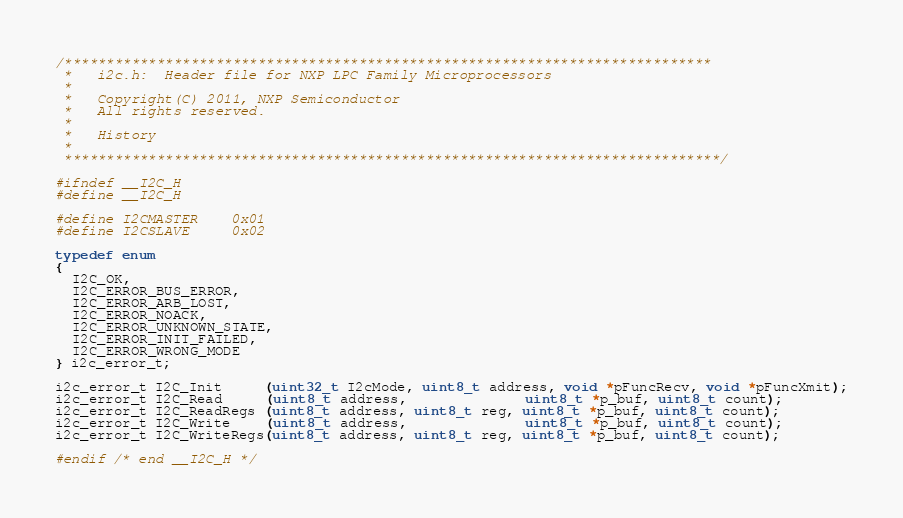Convert code to text. <code><loc_0><loc_0><loc_500><loc_500><_C_>/*****************************************************************************
 *   i2c.h:  Header file for NXP LPC Family Microprocessors
 *
 *   Copyright(C) 2011, NXP Semiconductor
 *   All rights reserved.
 *
 *   History
 *
 ******************************************************************************/

#ifndef __I2C_H
#define __I2C_H

#define I2CMASTER    0x01
#define I2CSLAVE     0x02

typedef enum
{
  I2C_OK,
  I2C_ERROR_BUS_ERROR,
  I2C_ERROR_ARB_LOST,
  I2C_ERROR_NOACK,
  I2C_ERROR_UNKNOWN_STATE,
  I2C_ERROR_INIT_FAILED,
  I2C_ERROR_WRONG_MODE
} i2c_error_t;

i2c_error_t I2C_Init     (uint32_t I2cMode, uint8_t address, void *pFuncRecv, void *pFuncXmit);
i2c_error_t I2C_Read     (uint8_t address,              uint8_t *p_buf, uint8_t count);
i2c_error_t I2C_ReadRegs (uint8_t address, uint8_t reg, uint8_t *p_buf, uint8_t count);
i2c_error_t I2C_Write    (uint8_t address,              uint8_t *p_buf, uint8_t count);
i2c_error_t I2C_WriteRegs(uint8_t address, uint8_t reg, uint8_t *p_buf, uint8_t count);

#endif /* end __I2C_H */
</code> 